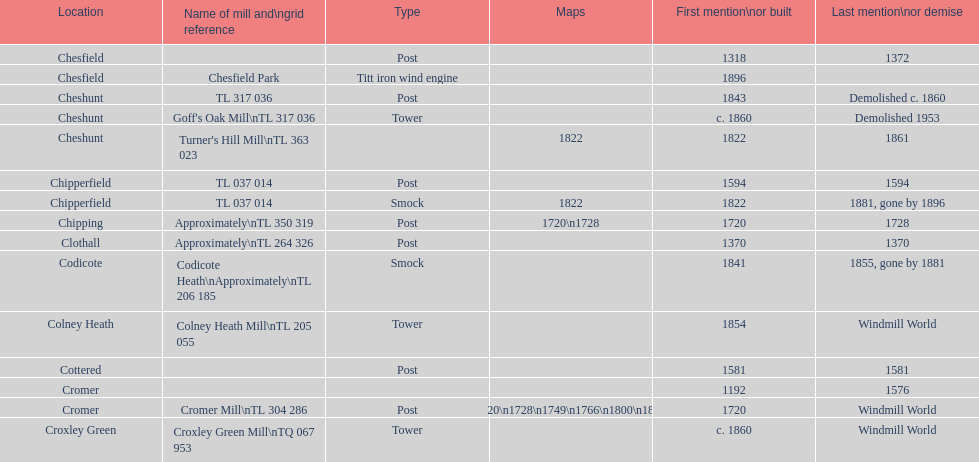Did cromer, chipperfield or cheshunt have the most windmills? Cheshunt. 